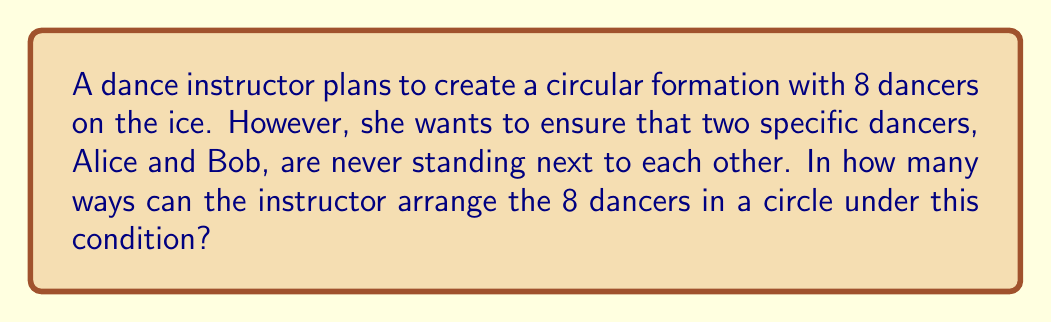Give your solution to this math problem. Let's approach this step-by-step:

1) First, consider the total number of ways to arrange 8 dancers in a circle without any restrictions:
   $$(8-1)! = 7! = 5040$$
   We use (8-1)! because in a circular arrangement, rotations are considered the same.

2) Now, let's count the number of arrangements where Alice and Bob are next to each other:
   a) Treat Alice and Bob as a single unit. Now we have 7 units to arrange (the Alice-Bob unit and 6 other dancers).
   b) The number of ways to arrange 7 units in a circle is $(7-1)! = 6! = 720$
   c) Alice and Bob can swap positions within their unit, so we multiply by 2:
      $$720 \times 2 = 1440$$

3) To find the number of arrangements where Alice and Bob are not next to each other, we subtract the number of arrangements where they are next to each other from the total number of arrangements:

   $$5040 - 1440 = 3600$$

Therefore, there are 3600 ways to arrange the 8 dancers in a circle such that Alice and Bob are never next to each other.
Answer: 3600 